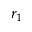Convert formula to latex. <formula><loc_0><loc_0><loc_500><loc_500>r _ { 1 }</formula> 